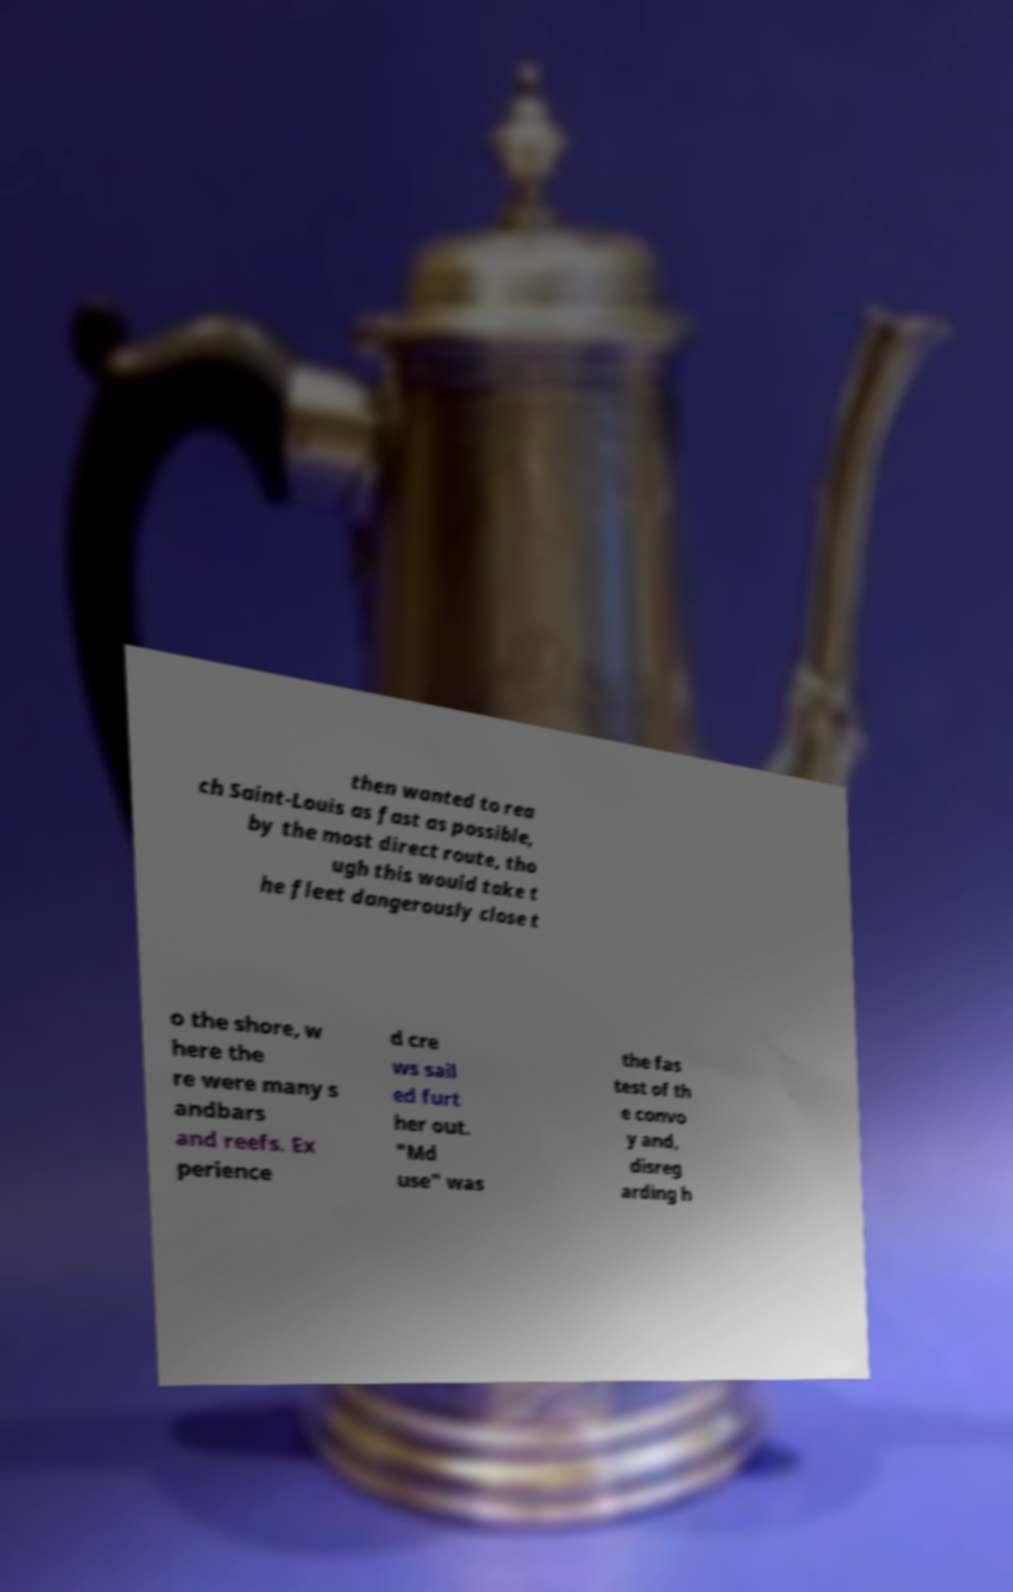Please read and relay the text visible in this image. What does it say? then wanted to rea ch Saint-Louis as fast as possible, by the most direct route, tho ugh this would take t he fleet dangerously close t o the shore, w here the re were many s andbars and reefs. Ex perience d cre ws sail ed furt her out. "Md use" was the fas test of th e convo y and, disreg arding h 